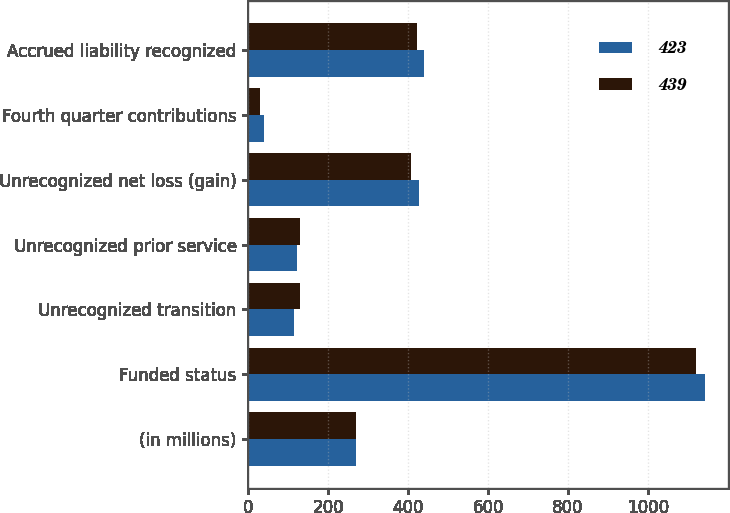<chart> <loc_0><loc_0><loc_500><loc_500><stacked_bar_chart><ecel><fcel>(in millions)<fcel>Funded status<fcel>Unrecognized transition<fcel>Unrecognized prior service<fcel>Unrecognized net loss (gain)<fcel>Fourth quarter contributions<fcel>Accrued liability recognized<nl><fcel>423<fcel>269<fcel>1142<fcel>114<fcel>121<fcel>428<fcel>40<fcel>439<nl><fcel>439<fcel>269<fcel>1120<fcel>129<fcel>130<fcel>408<fcel>30<fcel>423<nl></chart> 